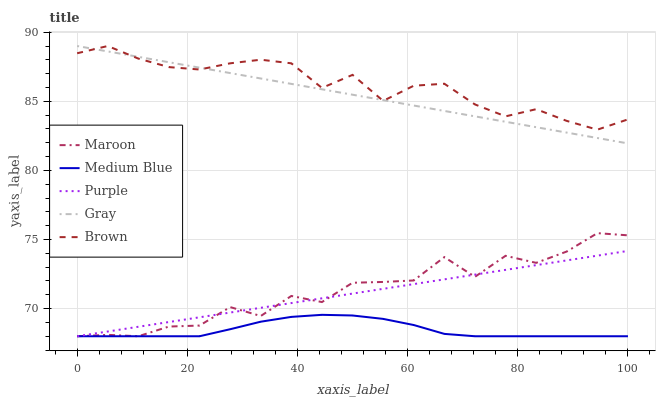Does Medium Blue have the minimum area under the curve?
Answer yes or no. Yes. Does Brown have the maximum area under the curve?
Answer yes or no. Yes. Does Gray have the minimum area under the curve?
Answer yes or no. No. Does Gray have the maximum area under the curve?
Answer yes or no. No. Is Gray the smoothest?
Answer yes or no. Yes. Is Maroon the roughest?
Answer yes or no. Yes. Is Medium Blue the smoothest?
Answer yes or no. No. Is Medium Blue the roughest?
Answer yes or no. No. Does Purple have the lowest value?
Answer yes or no. Yes. Does Gray have the lowest value?
Answer yes or no. No. Does Brown have the highest value?
Answer yes or no. Yes. Does Medium Blue have the highest value?
Answer yes or no. No. Is Maroon less than Brown?
Answer yes or no. Yes. Is Brown greater than Purple?
Answer yes or no. Yes. Does Purple intersect Medium Blue?
Answer yes or no. Yes. Is Purple less than Medium Blue?
Answer yes or no. No. Is Purple greater than Medium Blue?
Answer yes or no. No. Does Maroon intersect Brown?
Answer yes or no. No. 